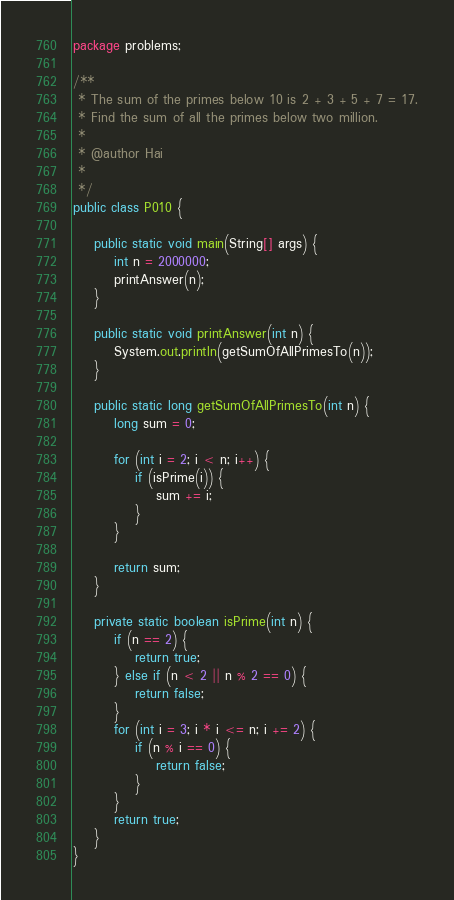<code> <loc_0><loc_0><loc_500><loc_500><_Java_>package problems;

/**
 * The sum of the primes below 10 is 2 + 3 + 5 + 7 = 17.
 * Find the sum of all the primes below two million.
 * 
 * @author Hai
 *
 */
public class P010 {

	public static void main(String[] args) {
		int n = 2000000;
		printAnswer(n);
	}
	
	public static void printAnswer(int n) {
		System.out.println(getSumOfAllPrimesTo(n));
	}
	
	public static long getSumOfAllPrimesTo(int n) {
		long sum = 0;

		for (int i = 2; i < n; i++) {
			if (isPrime(i)) {
				sum += i;
			}
		}

		return sum;
	}
	
	private static boolean isPrime(int n) {
		if (n == 2) {
			return true;
		} else if (n < 2 || n % 2 == 0) {
			return false;
		} 
		for (int i = 3; i * i <= n; i += 2) {
			if (n % i == 0) {
				return false;
			}
		}
		return true;
	}
}
</code> 